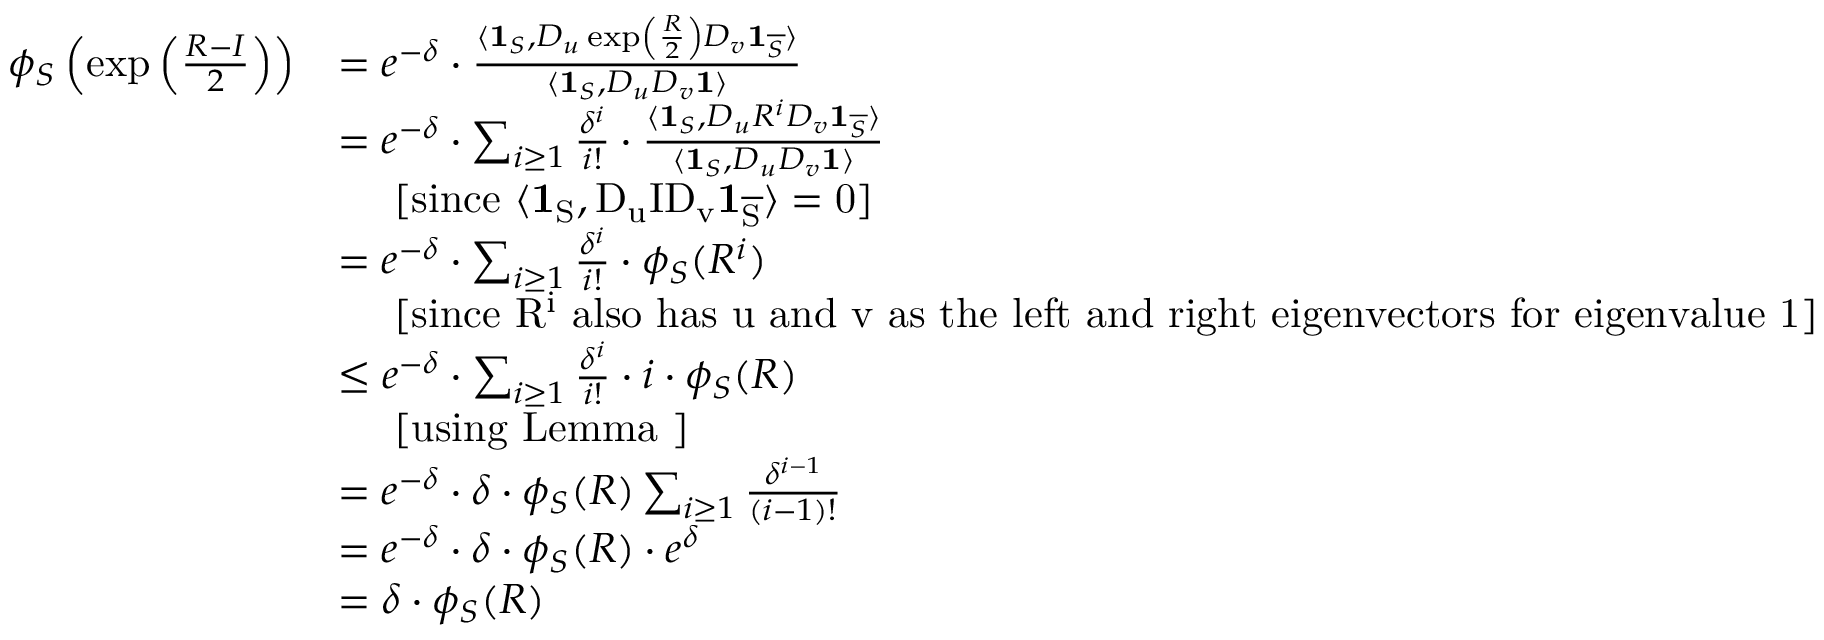<formula> <loc_0><loc_0><loc_500><loc_500>\begin{array} { r l } { \phi _ { S } \left ( \exp \left ( \frac { R - I } { 2 } \right ) \right ) } & { = e ^ { - \delta } \cdot \frac { \langle 1 _ { S } , D _ { u } \exp \left ( \frac { R } { 2 } \right ) D _ { v } 1 _ { \overline { S } } \rangle } { \langle 1 _ { S } , D _ { u } D _ { v } 1 \rangle } } \\ & { = e ^ { - \delta } \cdot \sum _ { i \geq 1 } \frac { \delta ^ { i } } { i ! } \cdot \frac { \langle 1 _ { S } , D _ { u } R ^ { i } D _ { v } 1 _ { \overline { S } } \rangle } { \langle 1 _ { S } , D _ { u } D _ { v } 1 \rangle } } \\ & { \quad [ \sin c e { \langle 1 _ { S } , D _ { u } I D _ { v } 1 _ { \overline { S } } \rangle = 0 } ] } \\ & { = e ^ { - \delta } \cdot \sum _ { i \geq 1 } \frac { \delta ^ { i } } { i ! } \cdot \phi _ { S } ( R ^ { i } ) } \\ & { \quad [ \sin c e { R ^ { i } } a l s o h a s { u } a n d { v } a s t h e l e f t a n d r i g h t e i g e n v e c t o r s f o r e i g e n v a l u e 1 ] } \\ & { \leq e ^ { - \delta } \cdot \sum _ { i \geq 1 } \frac { \delta ^ { i } } { i ! } \cdot i \cdot \phi _ { S } ( R ) } \\ & { \quad [ u \sin g L e m m a ] } \\ & { = e ^ { - \delta } \cdot \delta \cdot \phi _ { S } ( R ) \sum _ { i \geq 1 } \frac { \delta ^ { i - 1 } } { ( i - 1 ) ! } } \\ & { = e ^ { - \delta } \cdot \delta \cdot \phi _ { S } ( R ) \cdot e ^ { \delta } } \\ & { = \delta \cdot \phi _ { S } ( R ) } \end{array}</formula> 